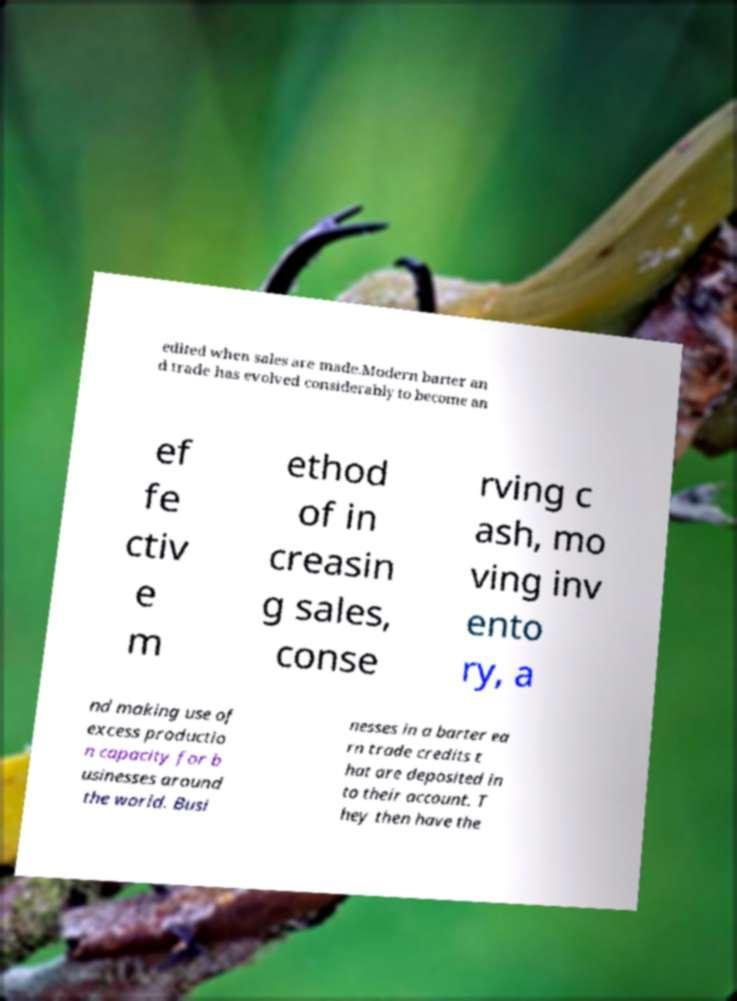For documentation purposes, I need the text within this image transcribed. Could you provide that? edited when sales are made.Modern barter an d trade has evolved considerably to become an ef fe ctiv e m ethod of in creasin g sales, conse rving c ash, mo ving inv ento ry, a nd making use of excess productio n capacity for b usinesses around the world. Busi nesses in a barter ea rn trade credits t hat are deposited in to their account. T hey then have the 